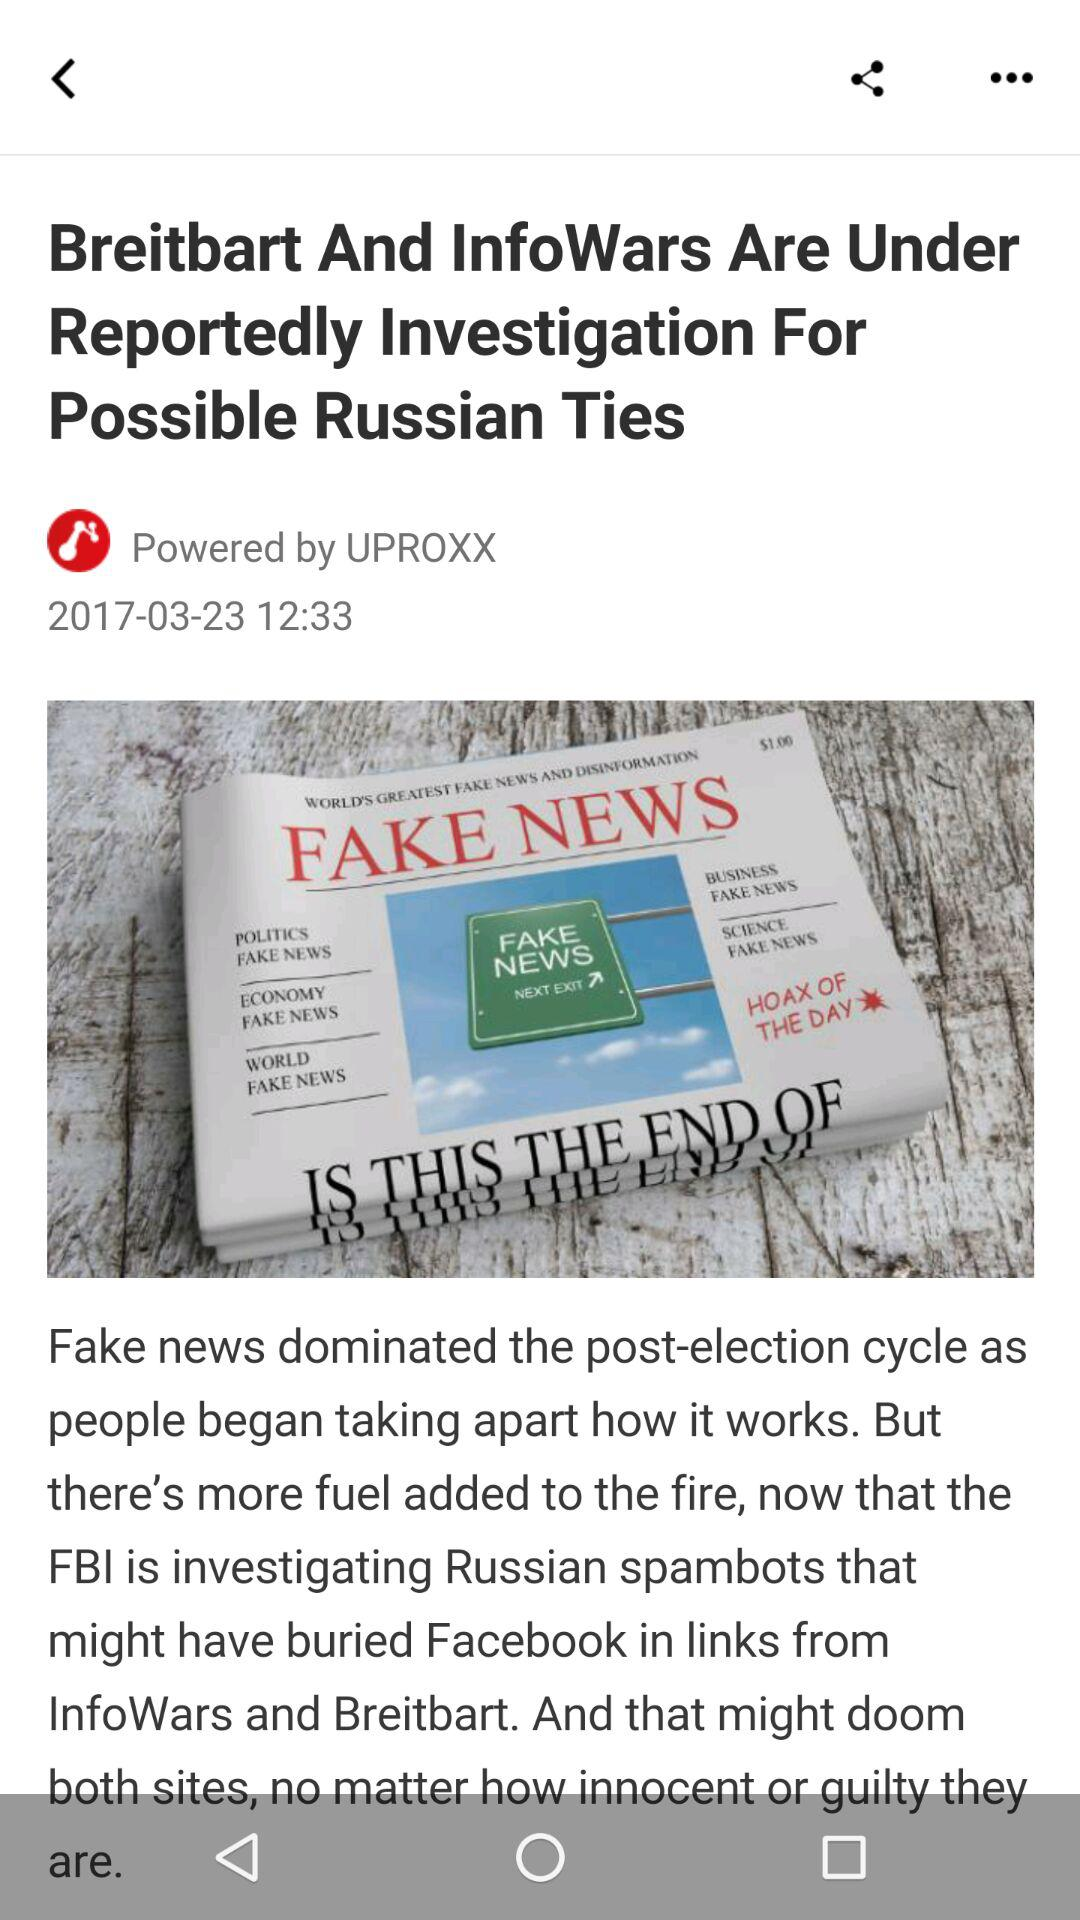What is the author name?
When the provided information is insufficient, respond with <no answer>. <no answer> 